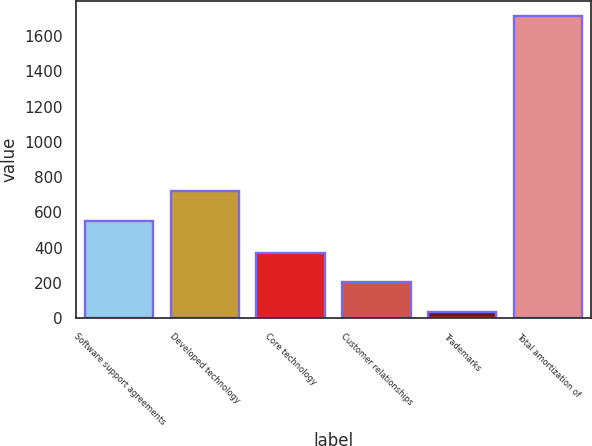Convert chart to OTSL. <chart><loc_0><loc_0><loc_500><loc_500><bar_chart><fcel>Software support agreements<fcel>Developed technology<fcel>Core technology<fcel>Customer relationships<fcel>Trademarks<fcel>Total amortization of<nl><fcel>549<fcel>722<fcel>372.2<fcel>204.6<fcel>37<fcel>1713<nl></chart> 